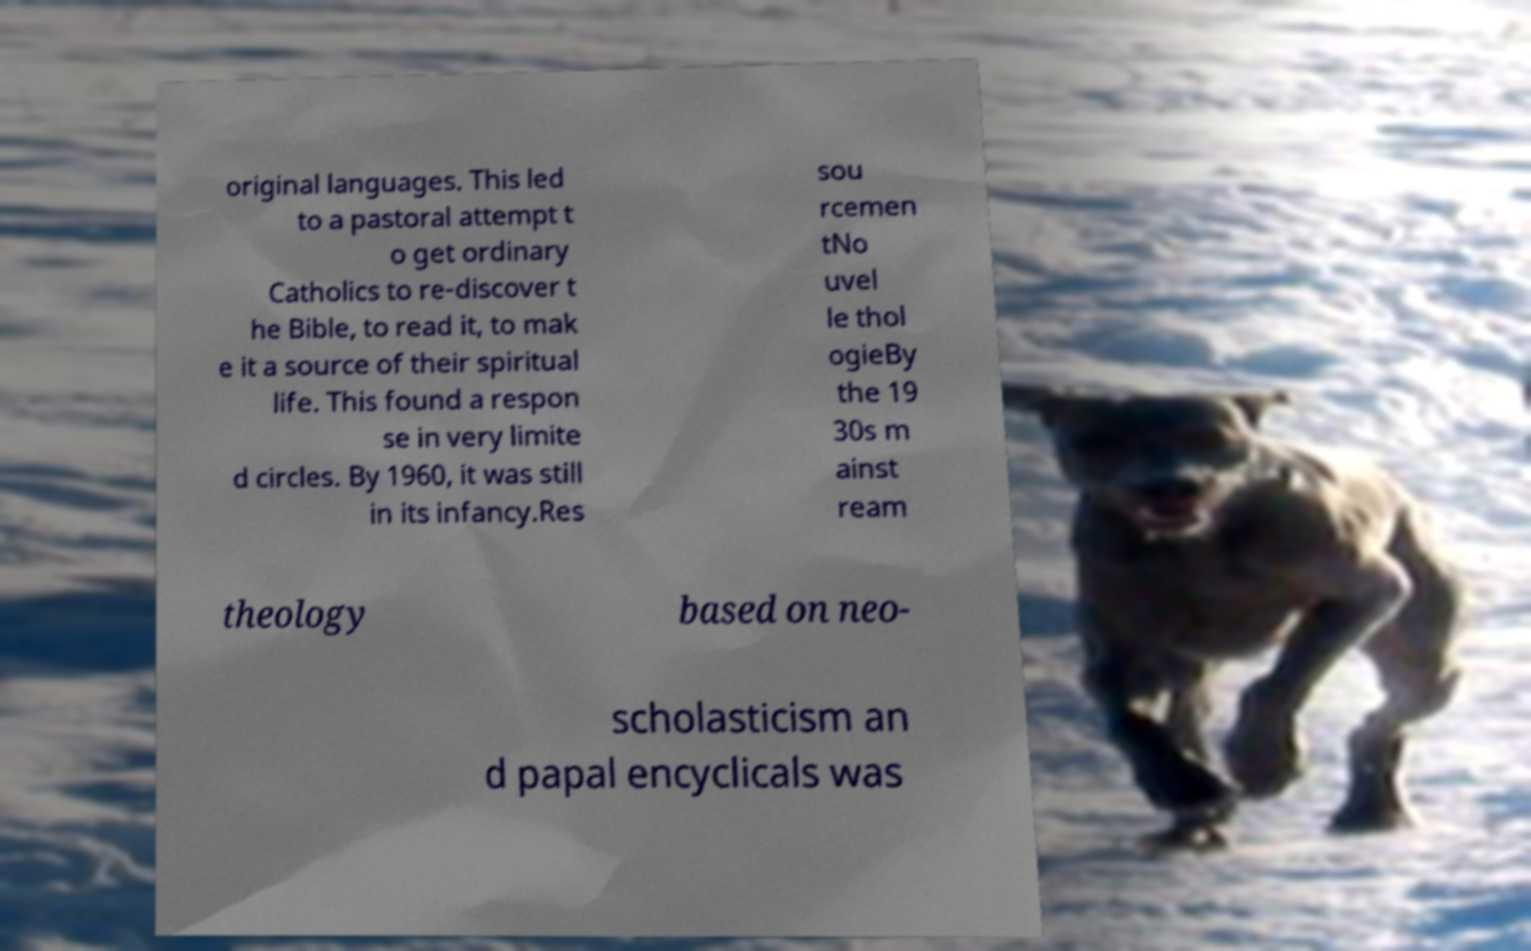For documentation purposes, I need the text within this image transcribed. Could you provide that? original languages. This led to a pastoral attempt t o get ordinary Catholics to re-discover t he Bible, to read it, to mak e it a source of their spiritual life. This found a respon se in very limite d circles. By 1960, it was still in its infancy.Res sou rcemen tNo uvel le thol ogieBy the 19 30s m ainst ream theology based on neo- scholasticism an d papal encyclicals was 